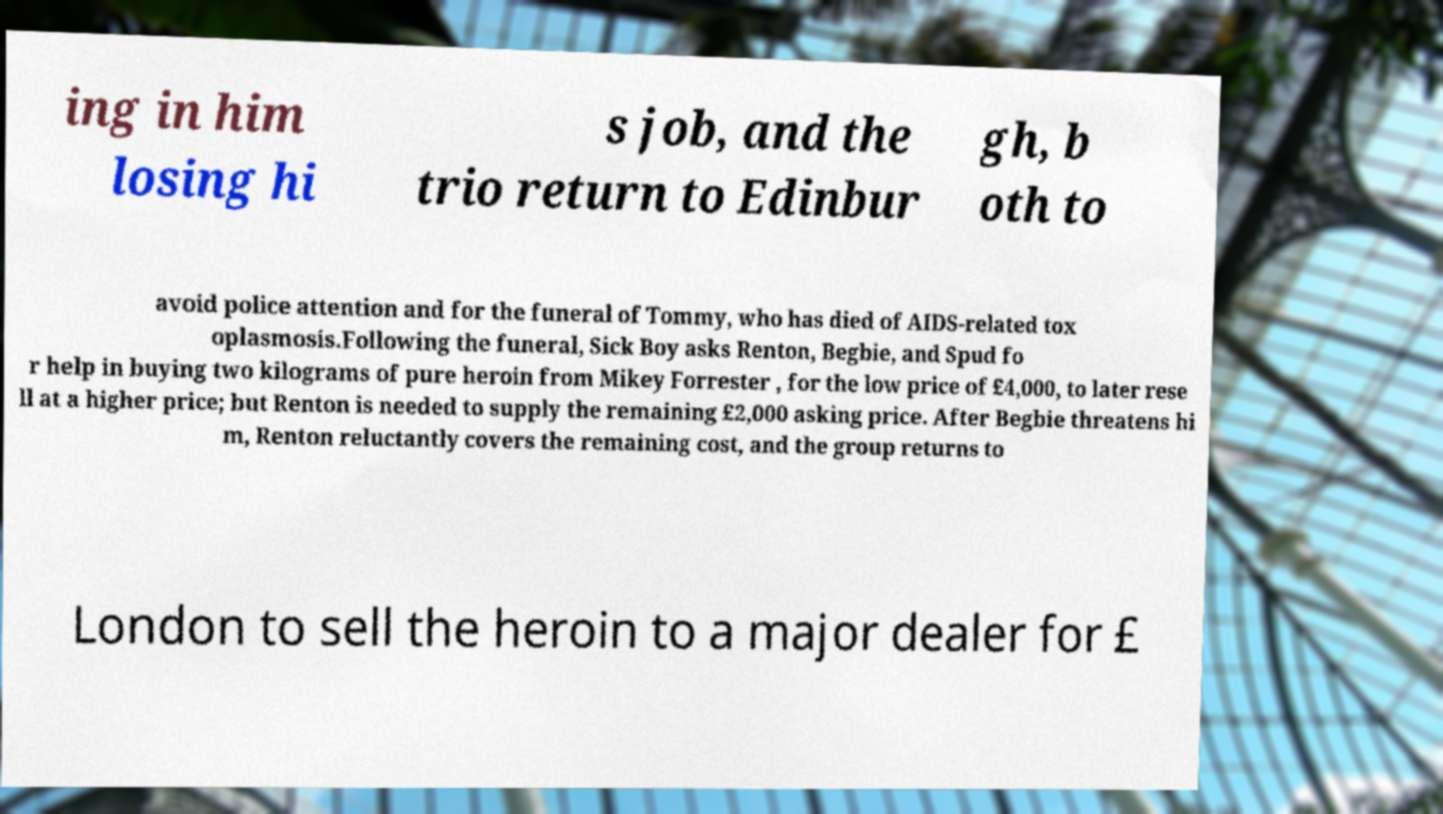There's text embedded in this image that I need extracted. Can you transcribe it verbatim? ing in him losing hi s job, and the trio return to Edinbur gh, b oth to avoid police attention and for the funeral of Tommy, who has died of AIDS-related tox oplasmosis.Following the funeral, Sick Boy asks Renton, Begbie, and Spud fo r help in buying two kilograms of pure heroin from Mikey Forrester , for the low price of £4,000, to later rese ll at a higher price; but Renton is needed to supply the remaining £2,000 asking price. After Begbie threatens hi m, Renton reluctantly covers the remaining cost, and the group returns to London to sell the heroin to a major dealer for £ 